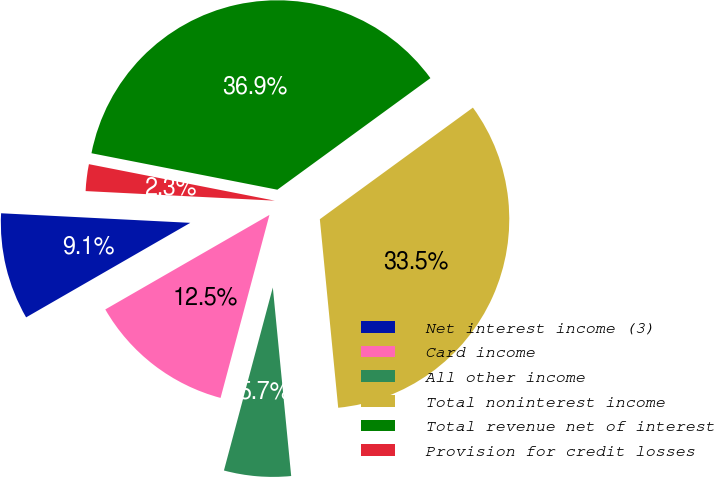Convert chart to OTSL. <chart><loc_0><loc_0><loc_500><loc_500><pie_chart><fcel>Net interest income (3)<fcel>Card income<fcel>All other income<fcel>Total noninterest income<fcel>Total revenue net of interest<fcel>Provision for credit losses<nl><fcel>9.12%<fcel>12.53%<fcel>5.7%<fcel>33.48%<fcel>36.89%<fcel>2.28%<nl></chart> 